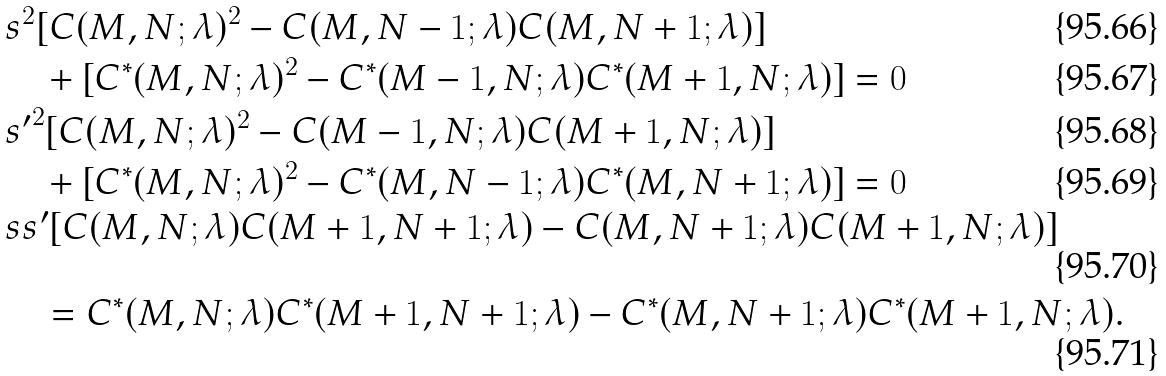<formula> <loc_0><loc_0><loc_500><loc_500>& s ^ { 2 } [ C ( M , N ; \lambda ) ^ { 2 } - C ( M , N - 1 ; \lambda ) C ( M , N + 1 ; \lambda ) ] \\ & \quad + [ C ^ { * } ( M , N ; \lambda ) ^ { 2 } - C ^ { * } ( M - 1 , N ; \lambda ) C ^ { * } ( M + 1 , N ; \lambda ) ] = 0 \\ & { s ^ { \prime } } ^ { 2 } [ C ( M , N ; \lambda ) ^ { 2 } - C ( M - 1 , N ; \lambda ) C ( M + 1 , N ; \lambda ) ] \\ & \quad + [ C ^ { * } ( M , N ; \lambda ) ^ { 2 } - C ^ { * } ( M , N - 1 ; \lambda ) C ^ { * } ( M , N + 1 ; \lambda ) ] = 0 \\ & s s ^ { \prime } [ C ( M , N ; \lambda ) C ( M + 1 , N + 1 ; \lambda ) - C ( M , N + 1 ; \lambda ) C ( M + 1 , N ; \lambda ) ] \\ & \quad = C ^ { * } ( M , N ; \lambda ) C ^ { * } ( M + 1 , N + 1 ; \lambda ) - C ^ { * } ( M , N + 1 ; \lambda ) C ^ { * } ( M + 1 , N ; \lambda ) .</formula> 